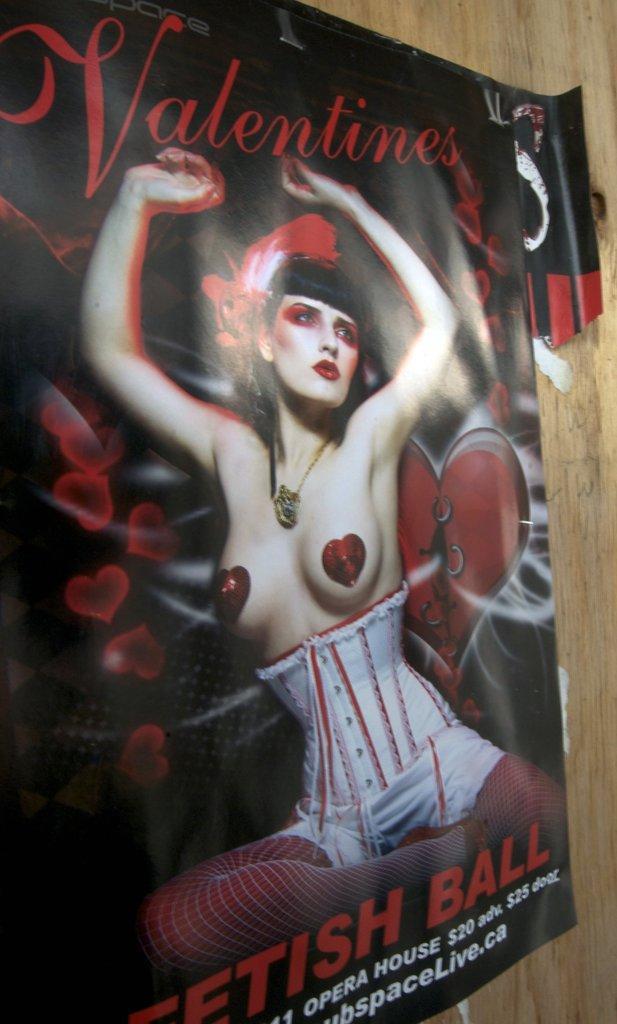In one or two sentences, can you explain what this image depicts? It the picture there is a poster of a woman stick to the wall. 